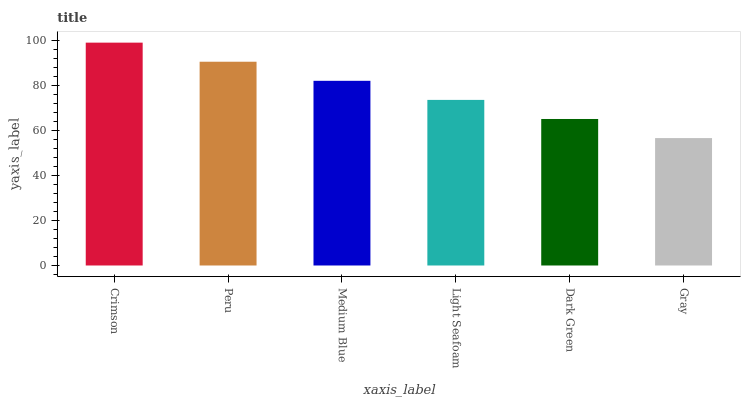Is Gray the minimum?
Answer yes or no. Yes. Is Crimson the maximum?
Answer yes or no. Yes. Is Peru the minimum?
Answer yes or no. No. Is Peru the maximum?
Answer yes or no. No. Is Crimson greater than Peru?
Answer yes or no. Yes. Is Peru less than Crimson?
Answer yes or no. Yes. Is Peru greater than Crimson?
Answer yes or no. No. Is Crimson less than Peru?
Answer yes or no. No. Is Medium Blue the high median?
Answer yes or no. Yes. Is Light Seafoam the low median?
Answer yes or no. Yes. Is Gray the high median?
Answer yes or no. No. Is Gray the low median?
Answer yes or no. No. 